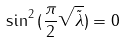<formula> <loc_0><loc_0><loc_500><loc_500>\sin ^ { 2 } { ( \frac { \pi } { 2 } \sqrt { \tilde { \lambda } } ) } = 0 \,</formula> 